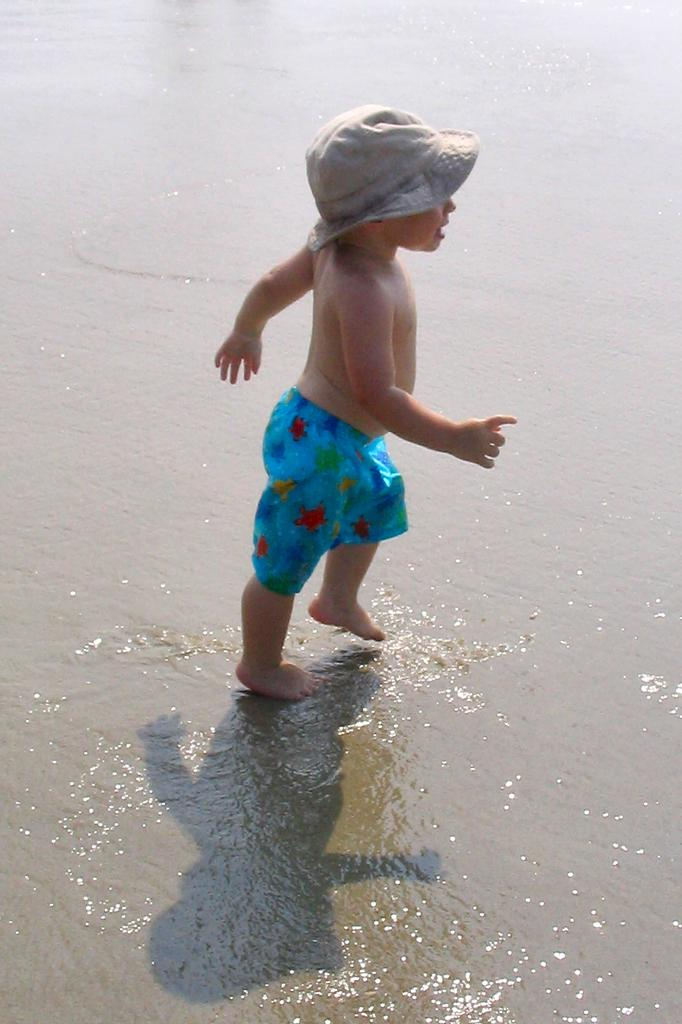What is the main subject of the image? There is a small boy in the center of the image. What is the boy wearing on his head? The boy is wearing a hat. What is the condition of the floor in the image? There is water on the floor in the image. What date is marked on the calendar in the image? There is no calendar present in the image. What achievement has the boy accomplished in the image? There is no indication of any achievement in the image; it simply shows a small boy wearing a hat and standing on a wet floor. 